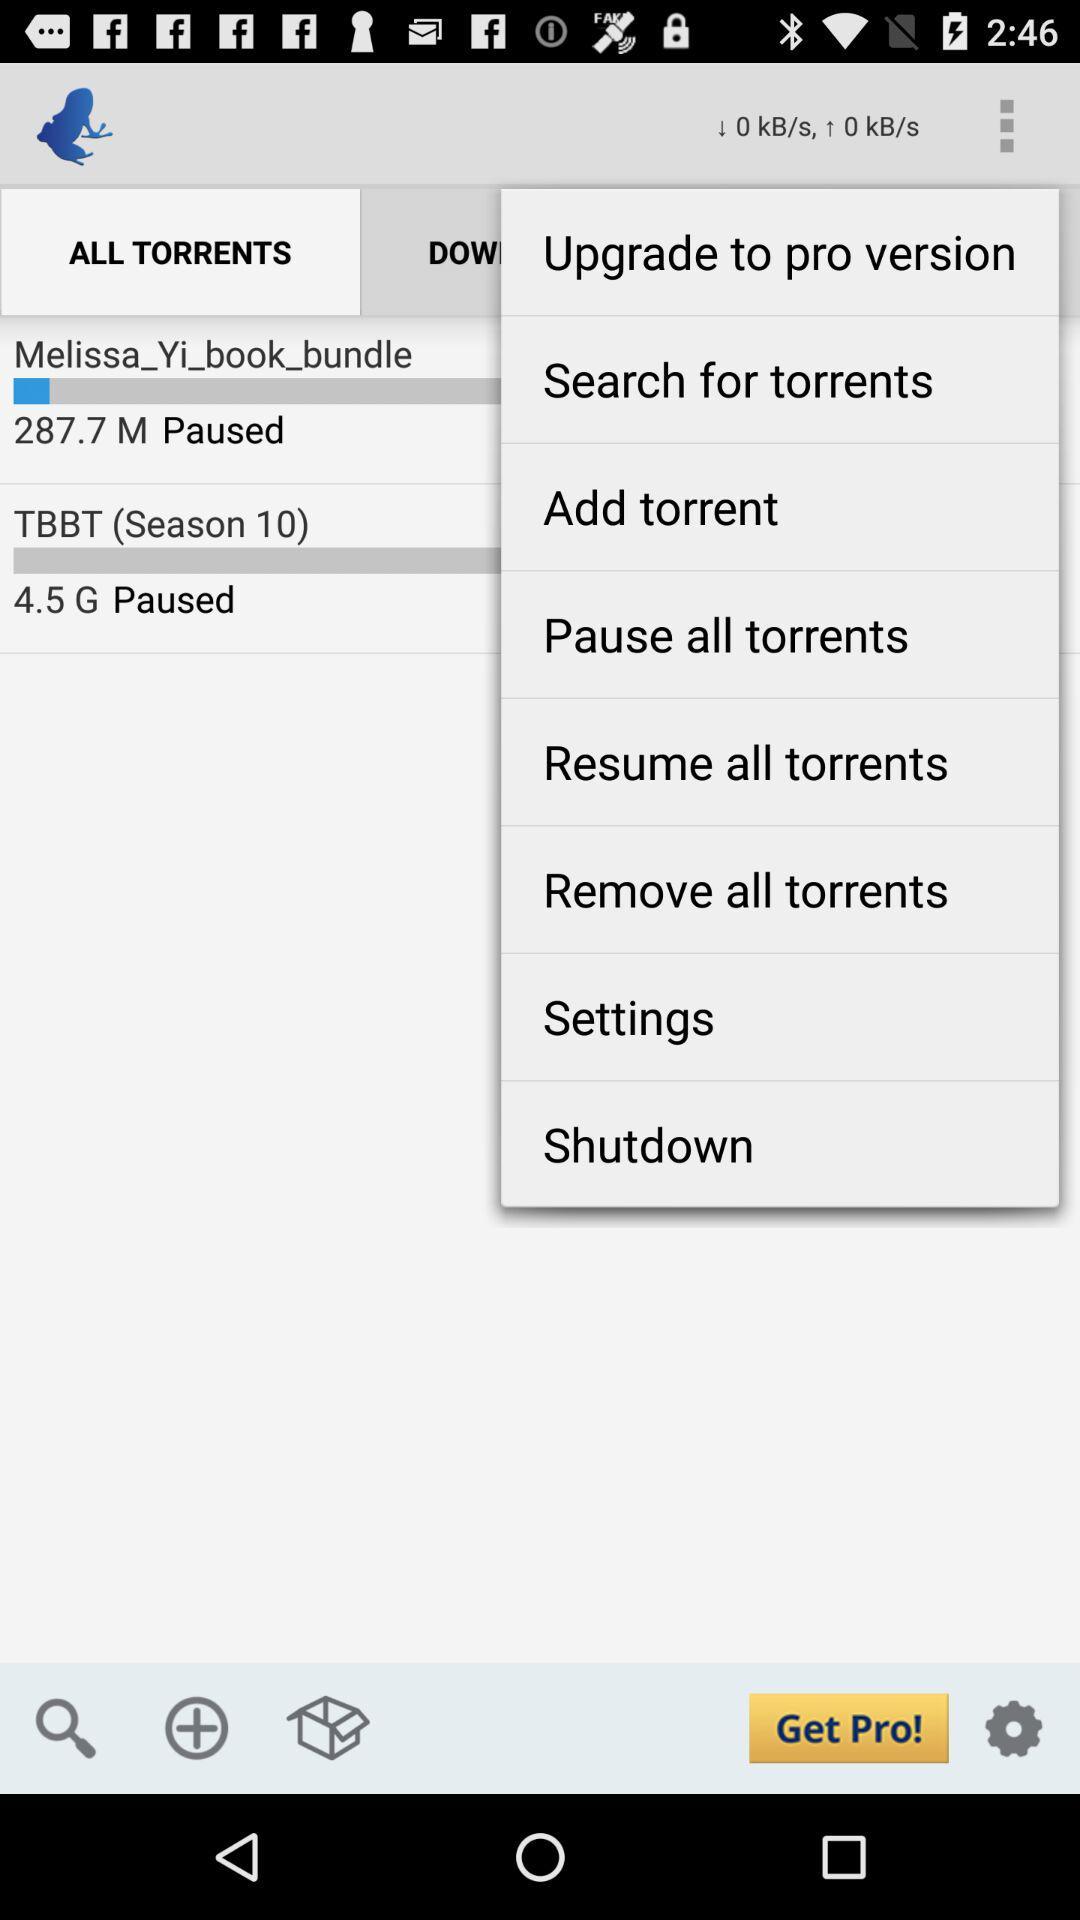What is the season of TBBT? The season of TBBT is 10. 